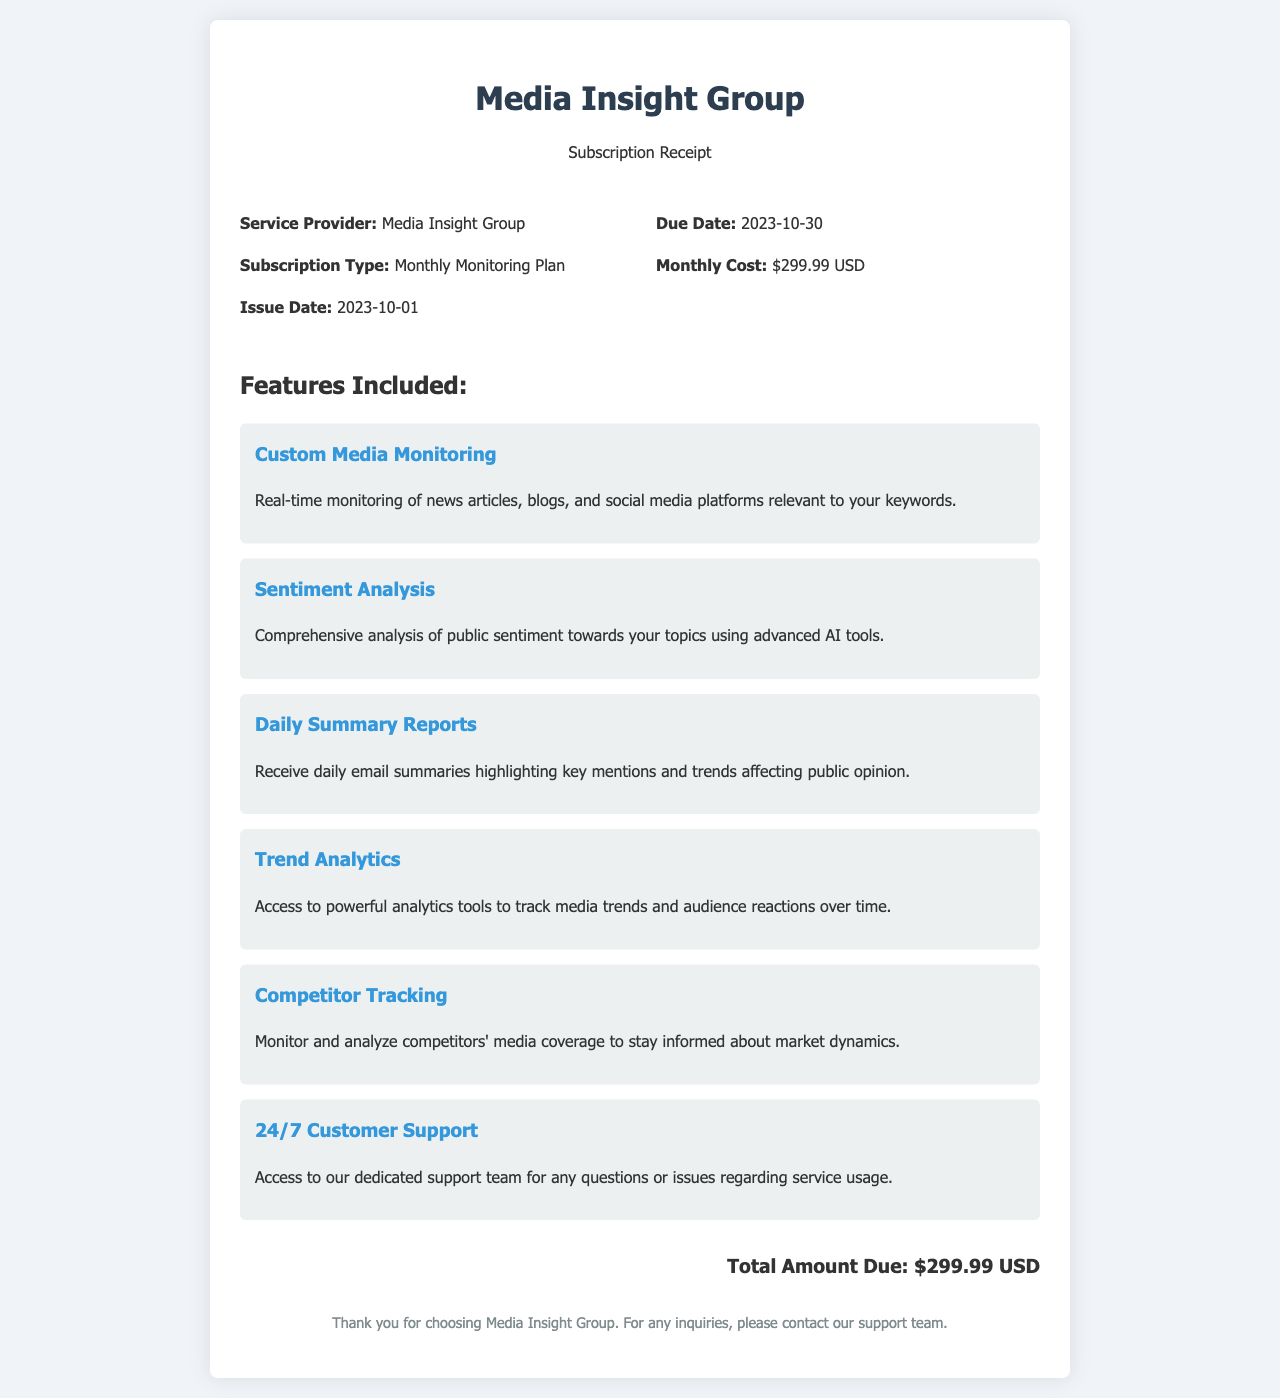What is the subscription type? The subscription type provided in the document is 'Monthly Monitoring Plan.'
Answer: Monthly Monitoring Plan What is the issue date of the receipt? The receipt states that the issue date is 2023-10-01.
Answer: 2023-10-01 What is the monthly cost listed in the receipt? The monthly cost mentioned in the document is $299.99 USD.
Answer: $299.99 USD Which feature provides real-time monitoring? The feature that provides real-time monitoring is 'Custom Media Monitoring.'
Answer: Custom Media Monitoring How many features are included in the subscription? The document lists a total of six features included in the subscription.
Answer: Six What is the due date for the payment? The due date for the payment as per the receipt is 2023-10-30.
Answer: 2023-10-30 What is included in the sentiment analysis feature? The sentiment analysis feature involves a comprehensive analysis of public sentiment using advanced AI tools.
Answer: Comprehensive analysis of public sentiment What kind of support is offered with the subscription? The document states that '24/7 Customer Support' is offered with the subscription.
Answer: 24/7 Customer Support What is the total amount due? The total amount due specified in the receipt is $299.99 USD.
Answer: $299.99 USD 